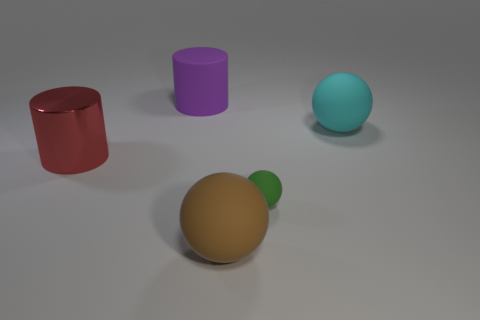Add 1 big rubber objects. How many objects exist? 6 Subtract all balls. How many objects are left? 2 Subtract all brown rubber balls. Subtract all brown things. How many objects are left? 3 Add 3 purple matte things. How many purple matte things are left? 4 Add 5 big purple rubber cylinders. How many big purple rubber cylinders exist? 6 Subtract 0 blue cylinders. How many objects are left? 5 